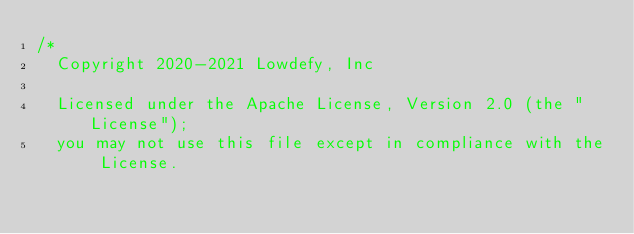Convert code to text. <code><loc_0><loc_0><loc_500><loc_500><_JavaScript_>/*
  Copyright 2020-2021 Lowdefy, Inc

  Licensed under the Apache License, Version 2.0 (the "License");
  you may not use this file except in compliance with the License.</code> 